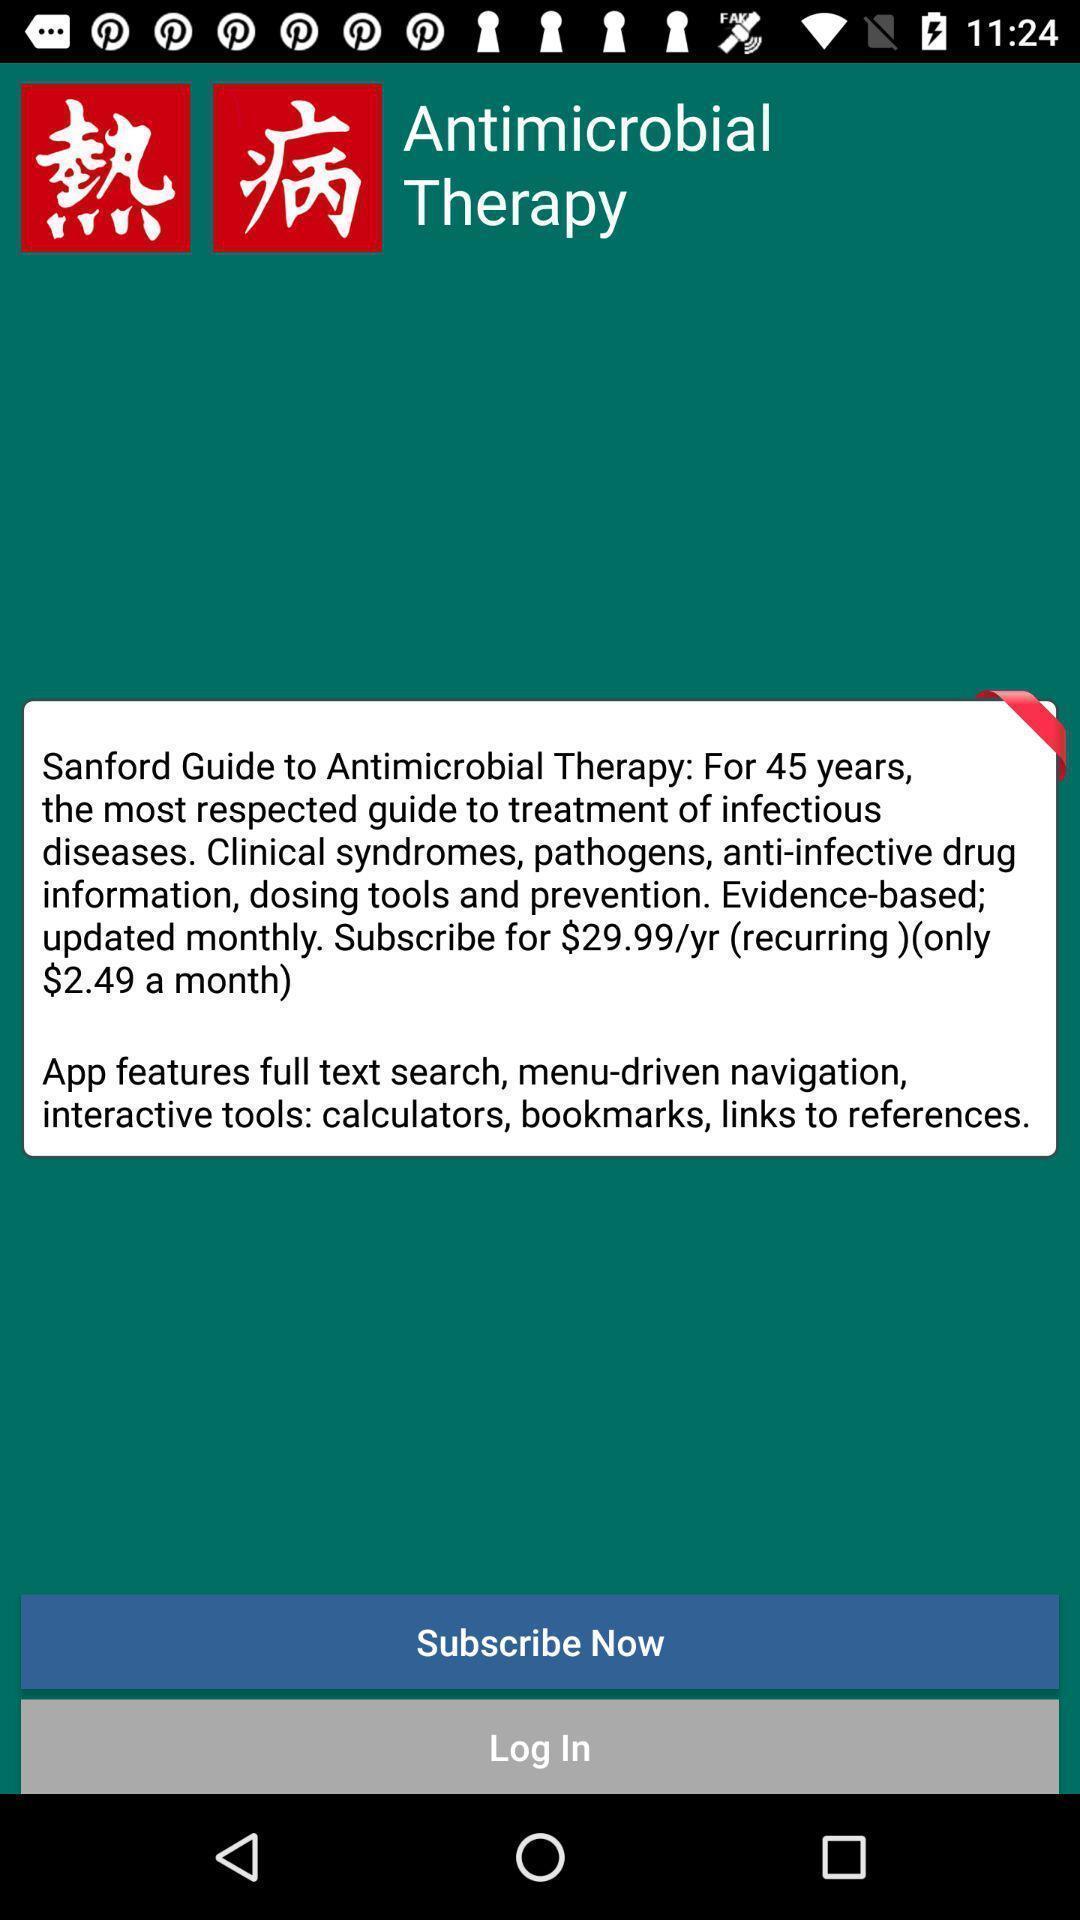Provide a detailed account of this screenshot. Welcome page displaying information to login or subscribe. 